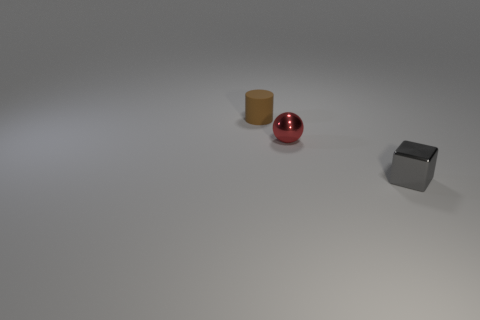Add 1 matte blocks. How many objects exist? 4 Subtract all cylinders. How many objects are left? 2 Add 1 gray metallic cubes. How many gray metallic cubes exist? 2 Subtract 1 gray cubes. How many objects are left? 2 Subtract all brown rubber things. Subtract all gray blocks. How many objects are left? 1 Add 2 tiny red metallic balls. How many tiny red metallic balls are left? 3 